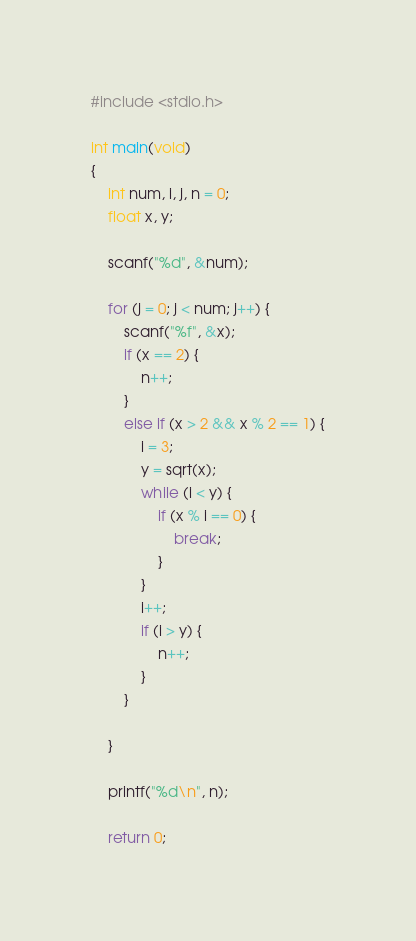Convert code to text. <code><loc_0><loc_0><loc_500><loc_500><_C_>#include <stdio.h>

int main(void)
{
	int num, i, j, n = 0;
	float x, y;

	scanf("%d", &num);

	for (j = 0; j < num; j++) {
		scanf("%f", &x);
		if (x == 2) {
			n++;
		}
		else if (x > 2 && x % 2 == 1) {
			i = 3;
			y = sqrt(x);
			while (i < y) {
				if (x % i == 0) {
					break;
				}
			}
			i++;
			if (i > y) {
				n++;
			}
		}

	}

	printf("%d\n", n);

	return 0;
</code> 